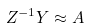Convert formula to latex. <formula><loc_0><loc_0><loc_500><loc_500>Z ^ { - 1 } Y \approx A</formula> 